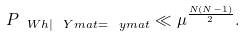<formula> <loc_0><loc_0><loc_500><loc_500>P _ { \ W h | \ Y m a t = \ y m a t } \ll \mu ^ { \frac { N ( N - 1 ) } { 2 } } .</formula> 